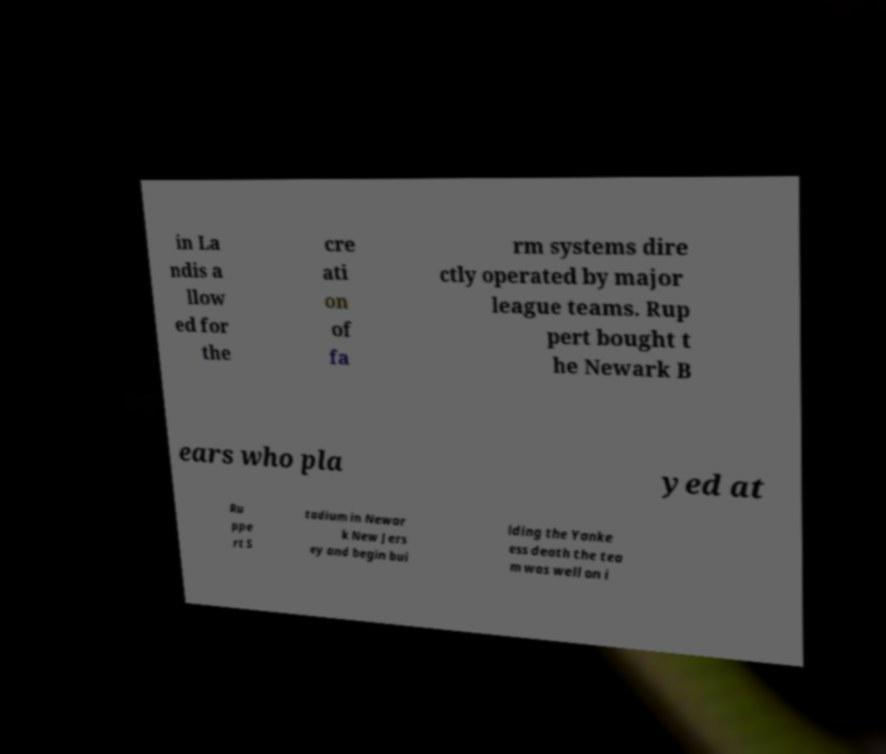Could you extract and type out the text from this image? in La ndis a llow ed for the cre ati on of fa rm systems dire ctly operated by major league teams. Rup pert bought t he Newark B ears who pla yed at Ru ppe rt S tadium in Newar k New Jers ey and begin bui lding the Yanke ess death the tea m was well on i 